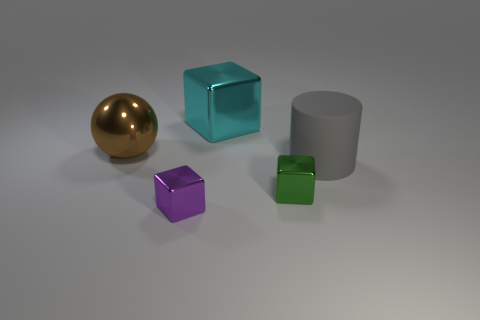What number of other objects are the same material as the gray thing?
Your response must be concise. 0. Is the material of the brown ball the same as the big gray cylinder?
Keep it short and to the point. No. The cyan object that is the same shape as the tiny purple thing is what size?
Give a very brief answer. Large. What number of things are right of the metallic cube that is behind the gray thing?
Keep it short and to the point. 2. How many other objects are the same shape as the large gray thing?
Your answer should be compact. 0. What number of blocks have the same color as the metal sphere?
Keep it short and to the point. 0. There is a large thing that is made of the same material as the sphere; what color is it?
Ensure brevity in your answer.  Cyan. Is there a matte cylinder that has the same size as the cyan metal thing?
Offer a terse response. Yes. Are there more large things that are right of the small purple cube than brown things that are left of the ball?
Offer a very short reply. Yes. Does the small purple object that is in front of the green cube have the same material as the cube to the right of the large cyan shiny block?
Your answer should be very brief. Yes. 